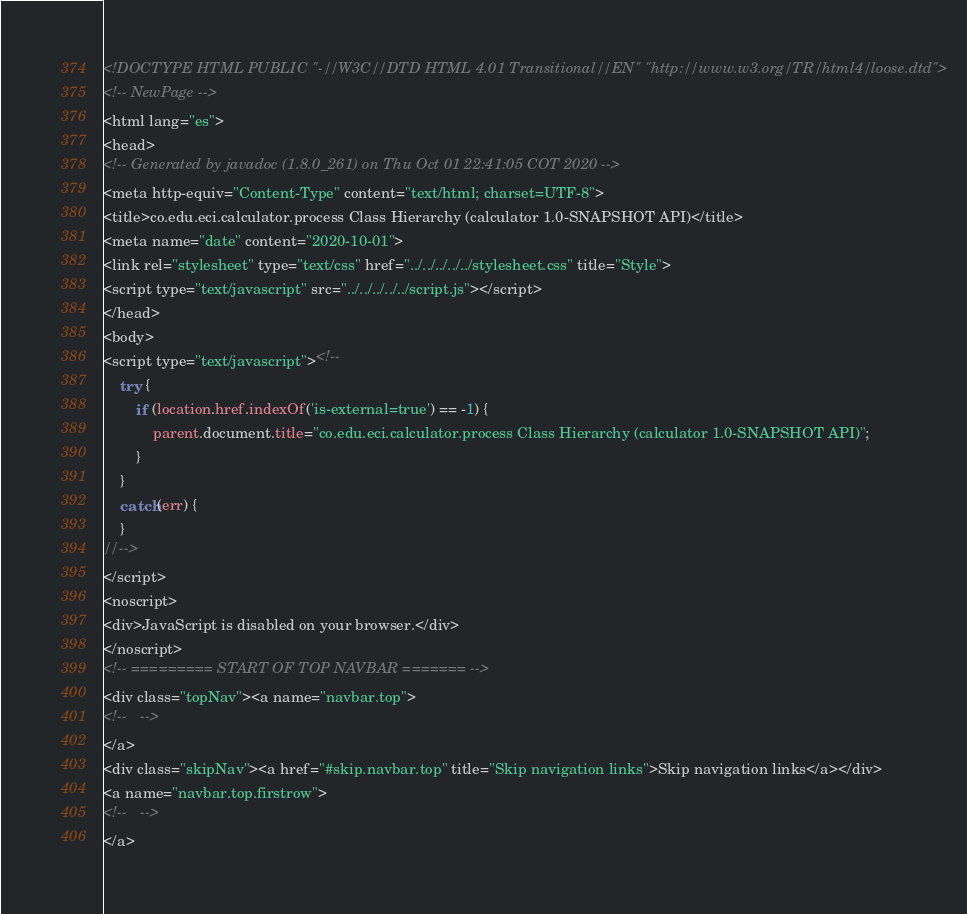<code> <loc_0><loc_0><loc_500><loc_500><_HTML_><!DOCTYPE HTML PUBLIC "-//W3C//DTD HTML 4.01 Transitional//EN" "http://www.w3.org/TR/html4/loose.dtd">
<!-- NewPage -->
<html lang="es">
<head>
<!-- Generated by javadoc (1.8.0_261) on Thu Oct 01 22:41:05 COT 2020 -->
<meta http-equiv="Content-Type" content="text/html; charset=UTF-8">
<title>co.edu.eci.calculator.process Class Hierarchy (calculator 1.0-SNAPSHOT API)</title>
<meta name="date" content="2020-10-01">
<link rel="stylesheet" type="text/css" href="../../../../../stylesheet.css" title="Style">
<script type="text/javascript" src="../../../../../script.js"></script>
</head>
<body>
<script type="text/javascript"><!--
    try {
        if (location.href.indexOf('is-external=true') == -1) {
            parent.document.title="co.edu.eci.calculator.process Class Hierarchy (calculator 1.0-SNAPSHOT API)";
        }
    }
    catch(err) {
    }
//-->
</script>
<noscript>
<div>JavaScript is disabled on your browser.</div>
</noscript>
<!-- ========= START OF TOP NAVBAR ======= -->
<div class="topNav"><a name="navbar.top">
<!--   -->
</a>
<div class="skipNav"><a href="#skip.navbar.top" title="Skip navigation links">Skip navigation links</a></div>
<a name="navbar.top.firstrow">
<!--   -->
</a></code> 